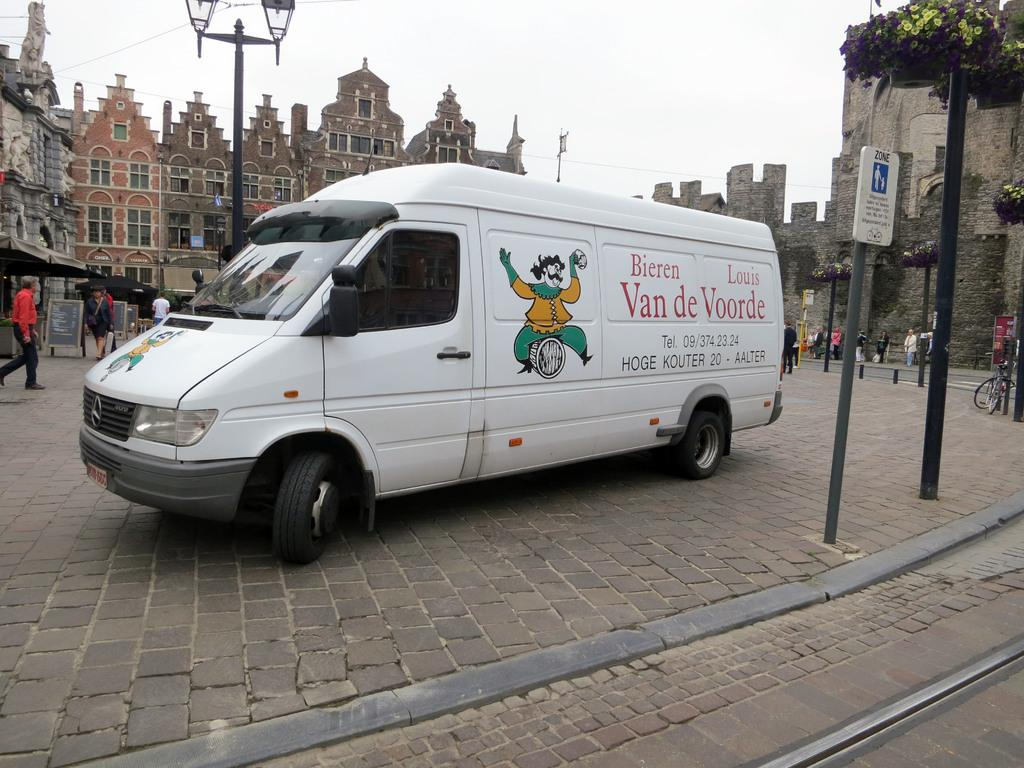<image>
Provide a brief description of the given image. a van de voorde ad that is on a van 